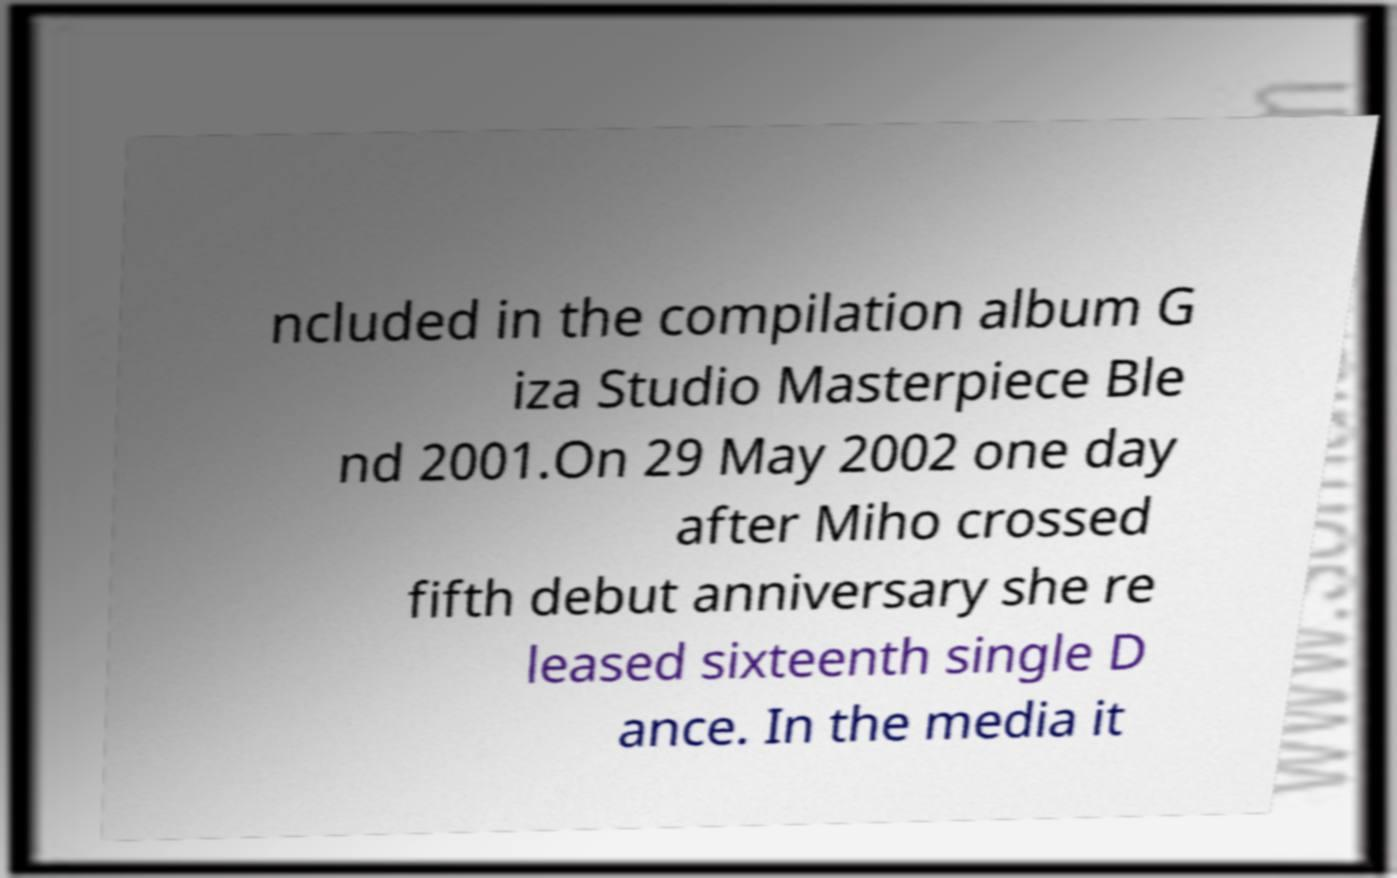For documentation purposes, I need the text within this image transcribed. Could you provide that? ncluded in the compilation album G iza Studio Masterpiece Ble nd 2001.On 29 May 2002 one day after Miho crossed fifth debut anniversary she re leased sixteenth single D ance. In the media it 